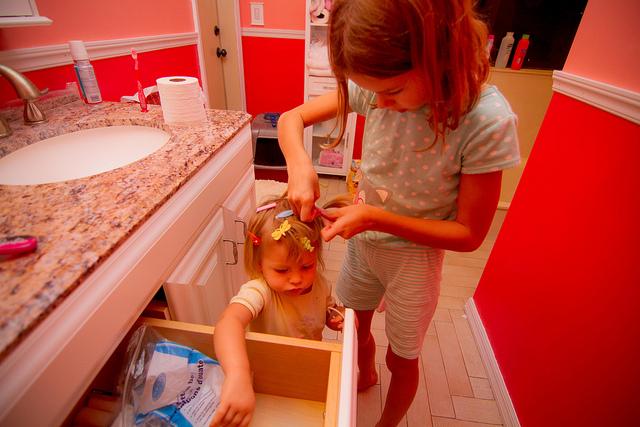In what room of the house are these girls in?
Give a very brief answer. Bathroom. How many clips in the little girls hair?
Write a very short answer. 5. Is the pink toothbrush standing up or laying down?
Concise answer only. Standing up. 